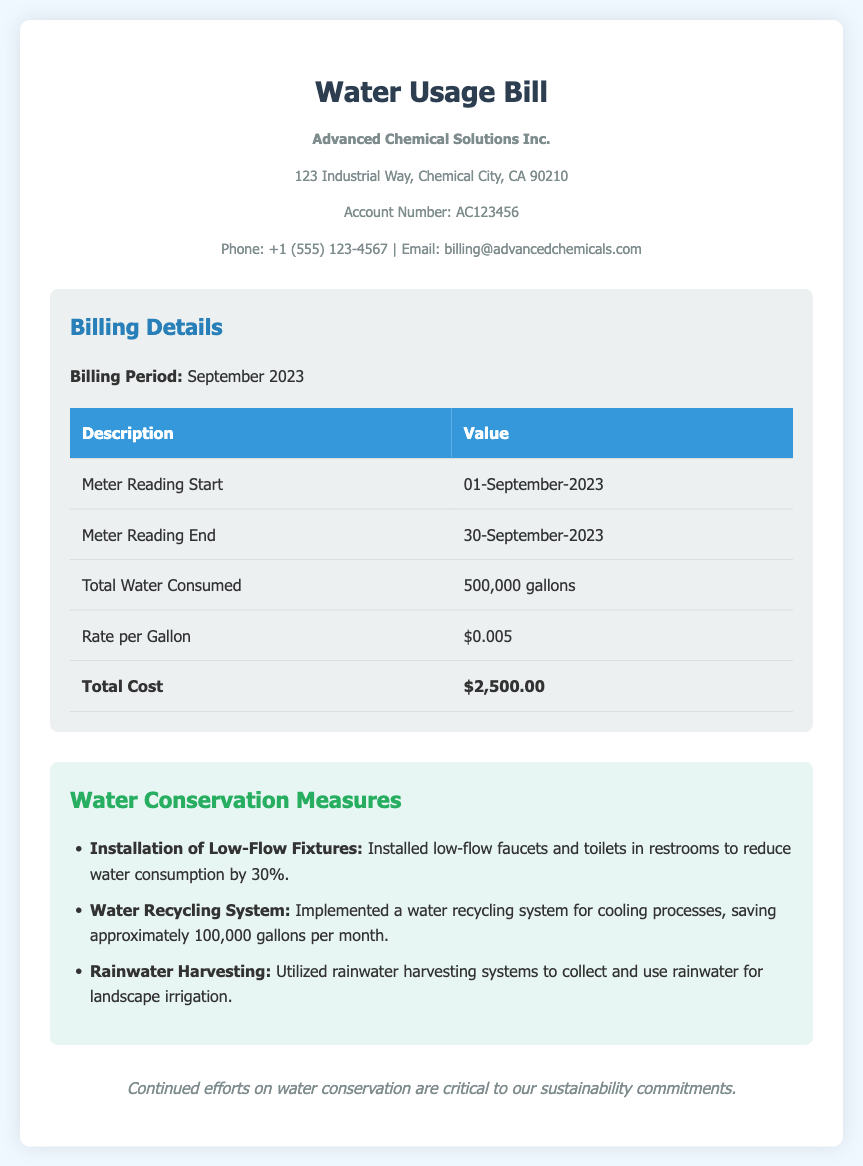what is the total water consumed? The total water consumed is provided in the billing details section, which states 500,000 gallons.
Answer: 500,000 gallons what is the rate per gallon? The rate per gallon is listed in the billing details section.
Answer: $0.005 what is the total cost of the bill? The total cost is presented as the last item in the billing details table, which is $2,500.00.
Answer: $2,500.00 what was the meter reading start date? The meter reading start date is stated in the billing details section as 01-September-2023.
Answer: 01-September-2023 what conservation measure saves approximately 100,000 gallons per month? The conservation measure that saves this volume is mentioned in the conservation measures section.
Answer: Water Recycling System what percentage reduction in water consumption does the low-flow fixtures provide? The document states that the installation of low-flow fixtures reduces water consumption by 30%.
Answer: 30% how long is the billing period for this bill? The billing period is specified at the top of the billing details section.
Answer: September 2023 what is the account number for Advanced Chemical Solutions Inc.? The account number is mentioned in the company information section of the document.
Answer: AC123456 what type of fixtures were installed to reduce water consumption? The document specifies the installed fixtures aimed at reducing consumption.
Answer: Low-Flow Fixtures 